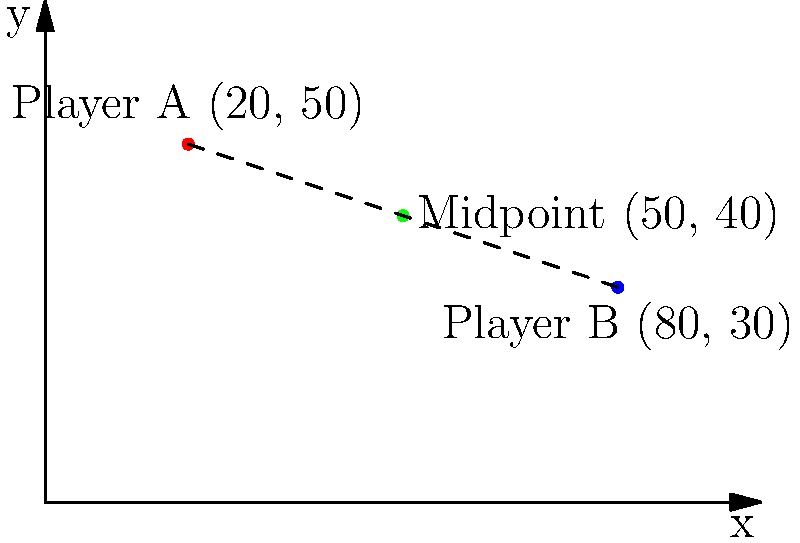During a match in the 1979-80 season, Player A was positioned at coordinates (20, 50) on the pitch, while Player B was at (80, 30). Calculate the coordinates of the midpoint between these two players. How would this information have been useful in strategizing play? To find the midpoint between two players on a football pitch using coordinates, we follow these steps:

1. Identify the coordinates of both players:
   Player A: $(x_1, y_1) = (20, 50)$
   Player B: $(x_2, y_2) = (80, 30)$

2. Use the midpoint formula:
   Midpoint = $(\frac{x_1 + x_2}{2}, \frac{y_1 + y_2}{2})$

3. Calculate the x-coordinate of the midpoint:
   $x_{mid} = \frac{x_1 + x_2}{2} = \frac{20 + 80}{2} = \frac{100}{2} = 50$

4. Calculate the y-coordinate of the midpoint:
   $y_{mid} = \frac{y_1 + y_2}{2} = \frac{50 + 30}{2} = \frac{80}{2} = 40$

5. Combine the results:
   Midpoint = $(50, 40)$

This information would have been useful in strategizing play because:
- It indicates the average position between the two players, which could be an ideal spot for a supporting teammate to occupy.
- It helps in understanding the spatial relationship between players, aiding in decision-making for passes, runs, and defensive positioning.
- Managers and coaches could use this data to analyze team formation and make tactical adjustments during the match.
Answer: (50, 40) 